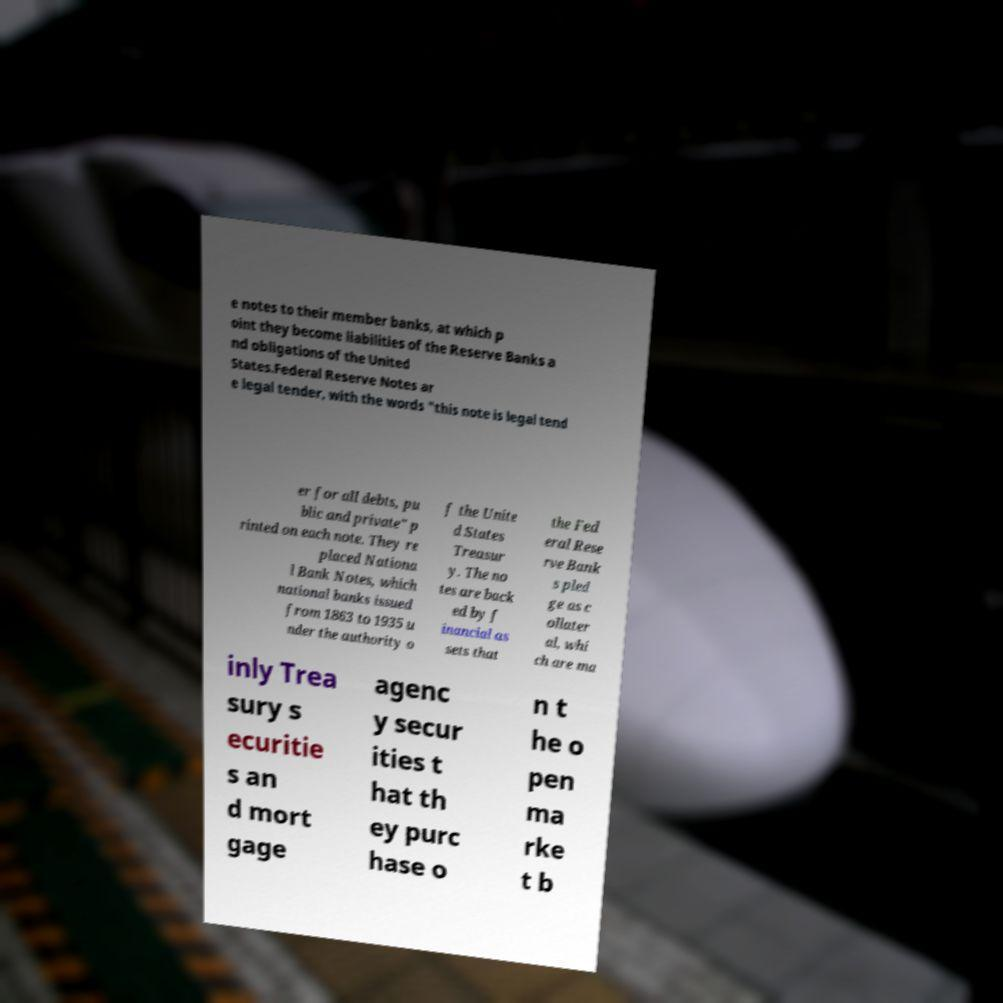Can you read and provide the text displayed in the image?This photo seems to have some interesting text. Can you extract and type it out for me? e notes to their member banks, at which p oint they become liabilities of the Reserve Banks a nd obligations of the United States.Federal Reserve Notes ar e legal tender, with the words "this note is legal tend er for all debts, pu blic and private" p rinted on each note. They re placed Nationa l Bank Notes, which national banks issued from 1863 to 1935 u nder the authority o f the Unite d States Treasur y. The no tes are back ed by f inancial as sets that the Fed eral Rese rve Bank s pled ge as c ollater al, whi ch are ma inly Trea sury s ecuritie s an d mort gage agenc y secur ities t hat th ey purc hase o n t he o pen ma rke t b 